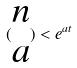<formula> <loc_0><loc_0><loc_500><loc_500>( \begin{matrix} n \\ a \end{matrix} ) < e ^ { a t }</formula> 